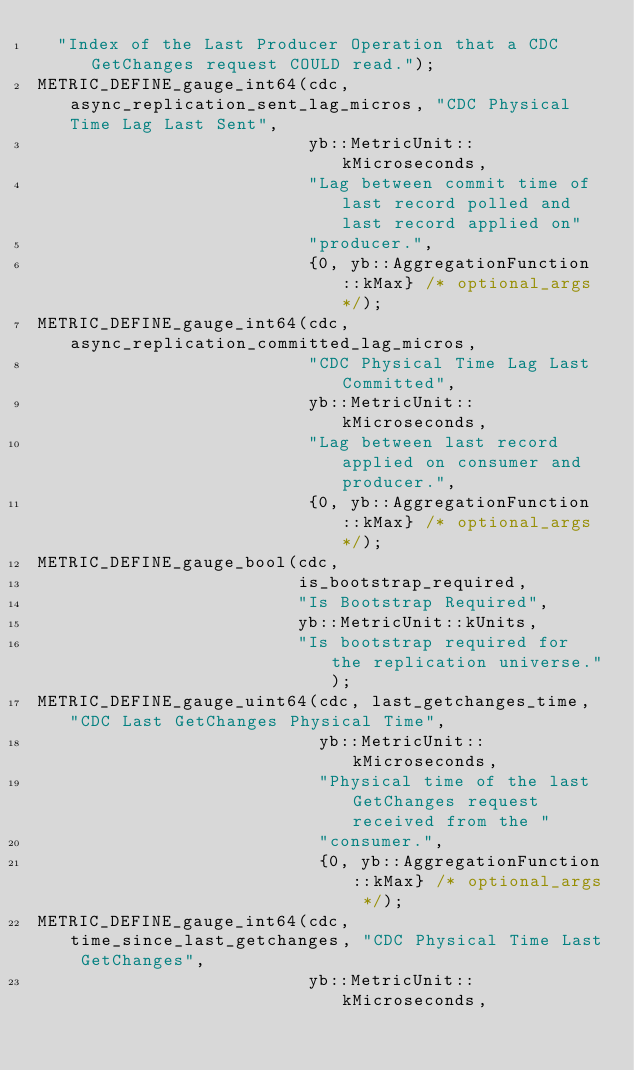Convert code to text. <code><loc_0><loc_0><loc_500><loc_500><_C++_>  "Index of the Last Producer Operation that a CDC GetChanges request COULD read.");
METRIC_DEFINE_gauge_int64(cdc, async_replication_sent_lag_micros, "CDC Physical Time Lag Last Sent",
                          yb::MetricUnit::kMicroseconds,
                          "Lag between commit time of last record polled and last record applied on"
                          "producer.",
                          {0, yb::AggregationFunction::kMax} /* optional_args */);
METRIC_DEFINE_gauge_int64(cdc, async_replication_committed_lag_micros,
                          "CDC Physical Time Lag Last Committed",
                          yb::MetricUnit::kMicroseconds,
                          "Lag between last record applied on consumer and producer.",
                          {0, yb::AggregationFunction::kMax} /* optional_args */);
METRIC_DEFINE_gauge_bool(cdc,
                         is_bootstrap_required,
                         "Is Bootstrap Required",
                         yb::MetricUnit::kUnits,
                         "Is bootstrap required for the replication universe.");
METRIC_DEFINE_gauge_uint64(cdc, last_getchanges_time, "CDC Last GetChanges Physical Time",
                           yb::MetricUnit::kMicroseconds,
                           "Physical time of the last GetChanges request received from the "
                           "consumer.",
                           {0, yb::AggregationFunction::kMax} /* optional_args */);
METRIC_DEFINE_gauge_int64(cdc, time_since_last_getchanges, "CDC Physical Time Last GetChanges",
                          yb::MetricUnit::kMicroseconds,</code> 